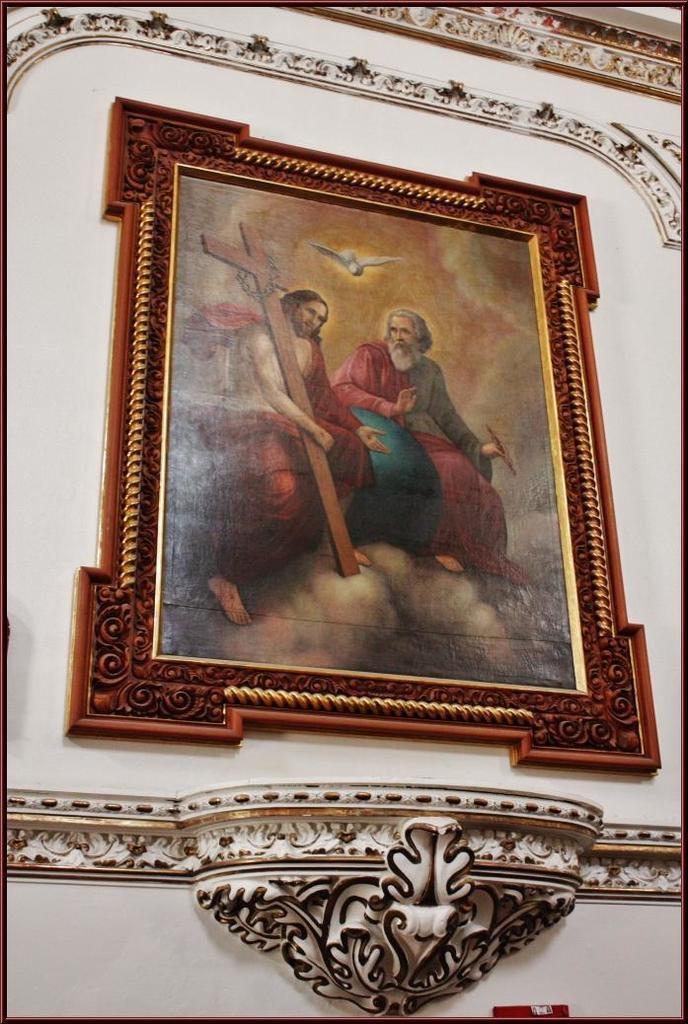In one or two sentences, can you explain what this image depicts? In this image we can see a brown color photo frame is attached to white color wall. 